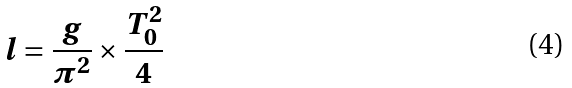Convert formula to latex. <formula><loc_0><loc_0><loc_500><loc_500>l = \frac { g } { \pi ^ { 2 } } \times \frac { T _ { 0 } ^ { 2 } } { 4 }</formula> 